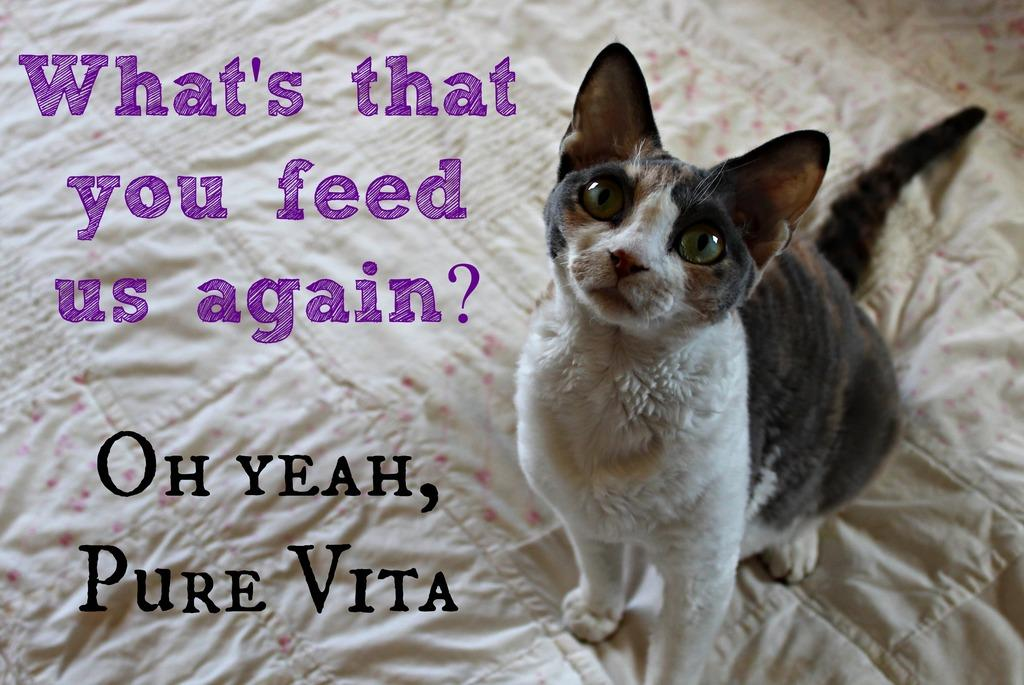What type of animal is on the right side of the image? There is a cat on the right side of the image. What can be seen on the left side of the image? There is some text on the left side of the image. What type of guitar is being played by the cat in the image? There is no guitar present in the image; it features a cat and some text. What color is the ink used for the text in the image? There is no information about the color of the ink used for the text in the image. 